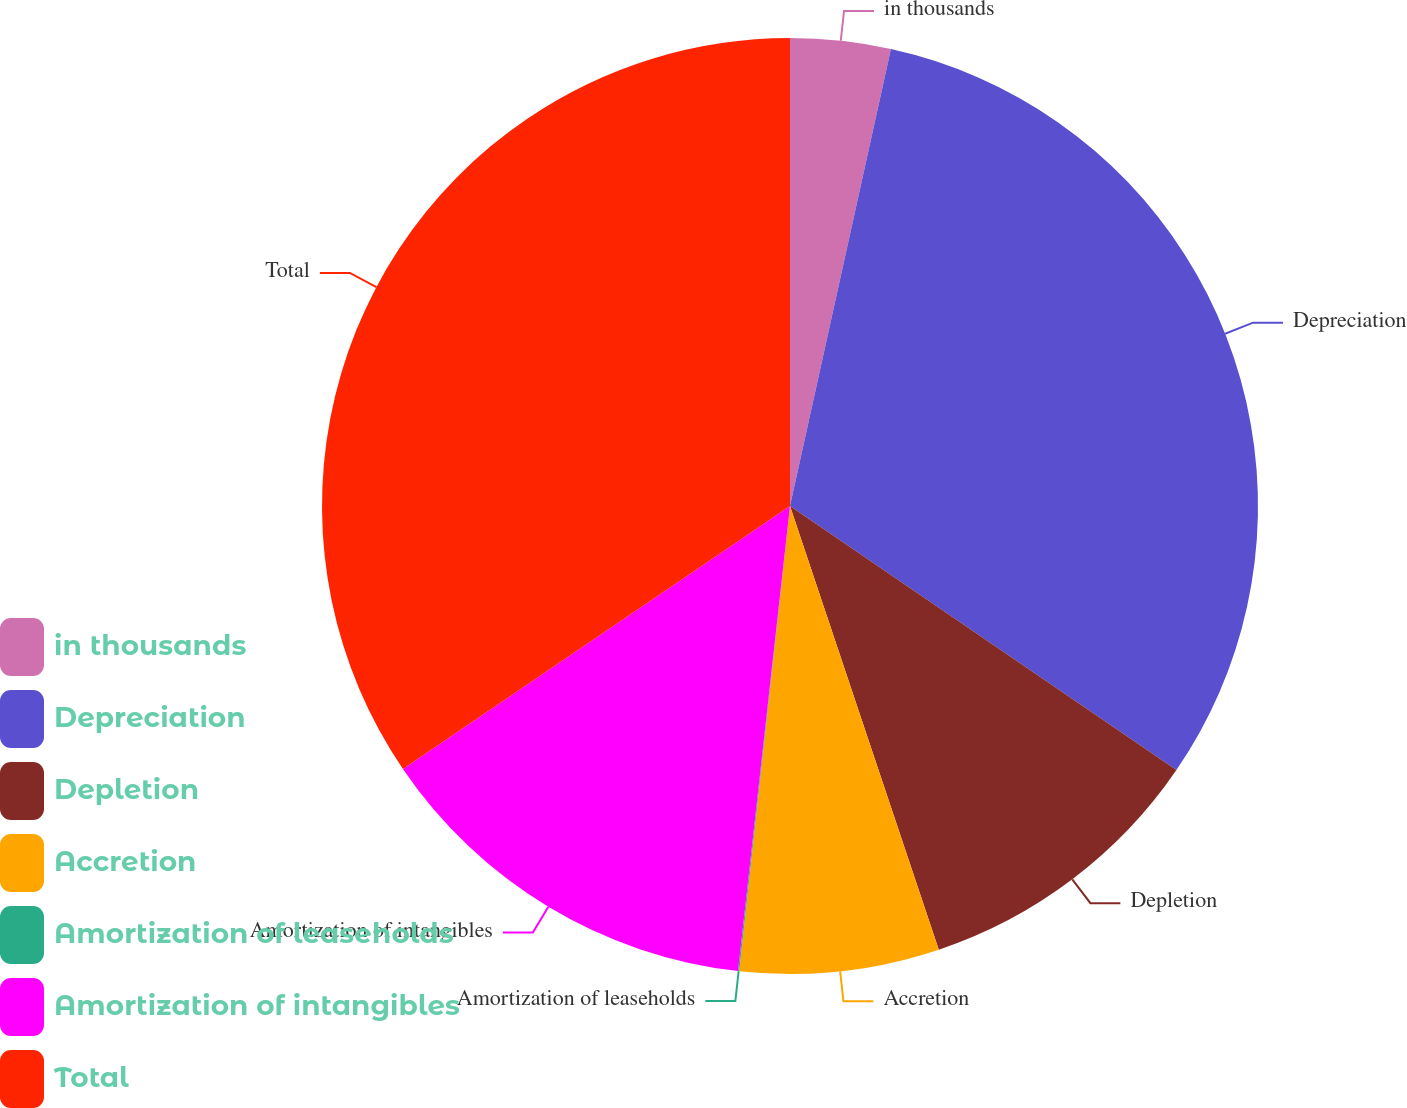<chart> <loc_0><loc_0><loc_500><loc_500><pie_chart><fcel>in thousands<fcel>Depreciation<fcel>Depletion<fcel>Accretion<fcel>Amortization of leaseholds<fcel>Amortization of intangibles<fcel>Total<nl><fcel>3.46%<fcel>31.08%<fcel>10.31%<fcel>6.88%<fcel>0.04%<fcel>13.73%<fcel>34.5%<nl></chart> 